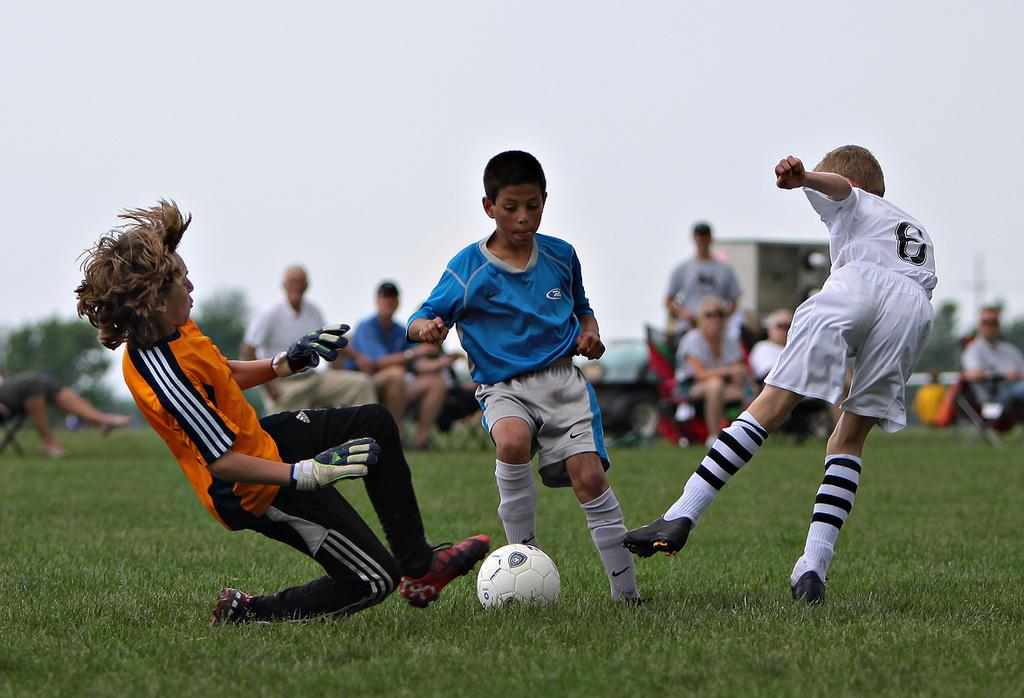What are the three boys in the image doing? The three boys are playing football in the image. Where is the football game taking place? The football game is taking place on a green field. Are there any spectators in the image? Yes, there are people seated and watching the game, as well as a man standing and watching the game. How many ladybugs can be seen crawling on the football in the image? There are no ladybugs present in the image; it features a football game with boys playing football on a green field. What type of crate is being used to store the football equipment in the image? There is no crate visible in the image; it only shows the boys playing football, spectators watching the game, and the green field. 